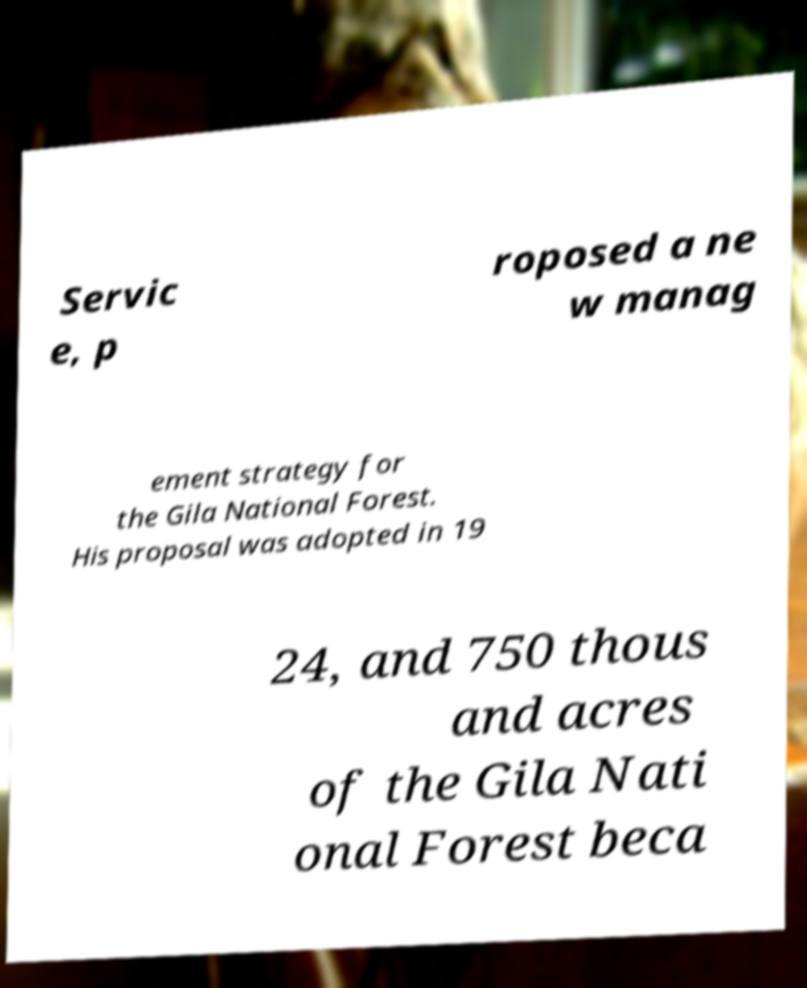Can you accurately transcribe the text from the provided image for me? Servic e, p roposed a ne w manag ement strategy for the Gila National Forest. His proposal was adopted in 19 24, and 750 thous and acres of the Gila Nati onal Forest beca 